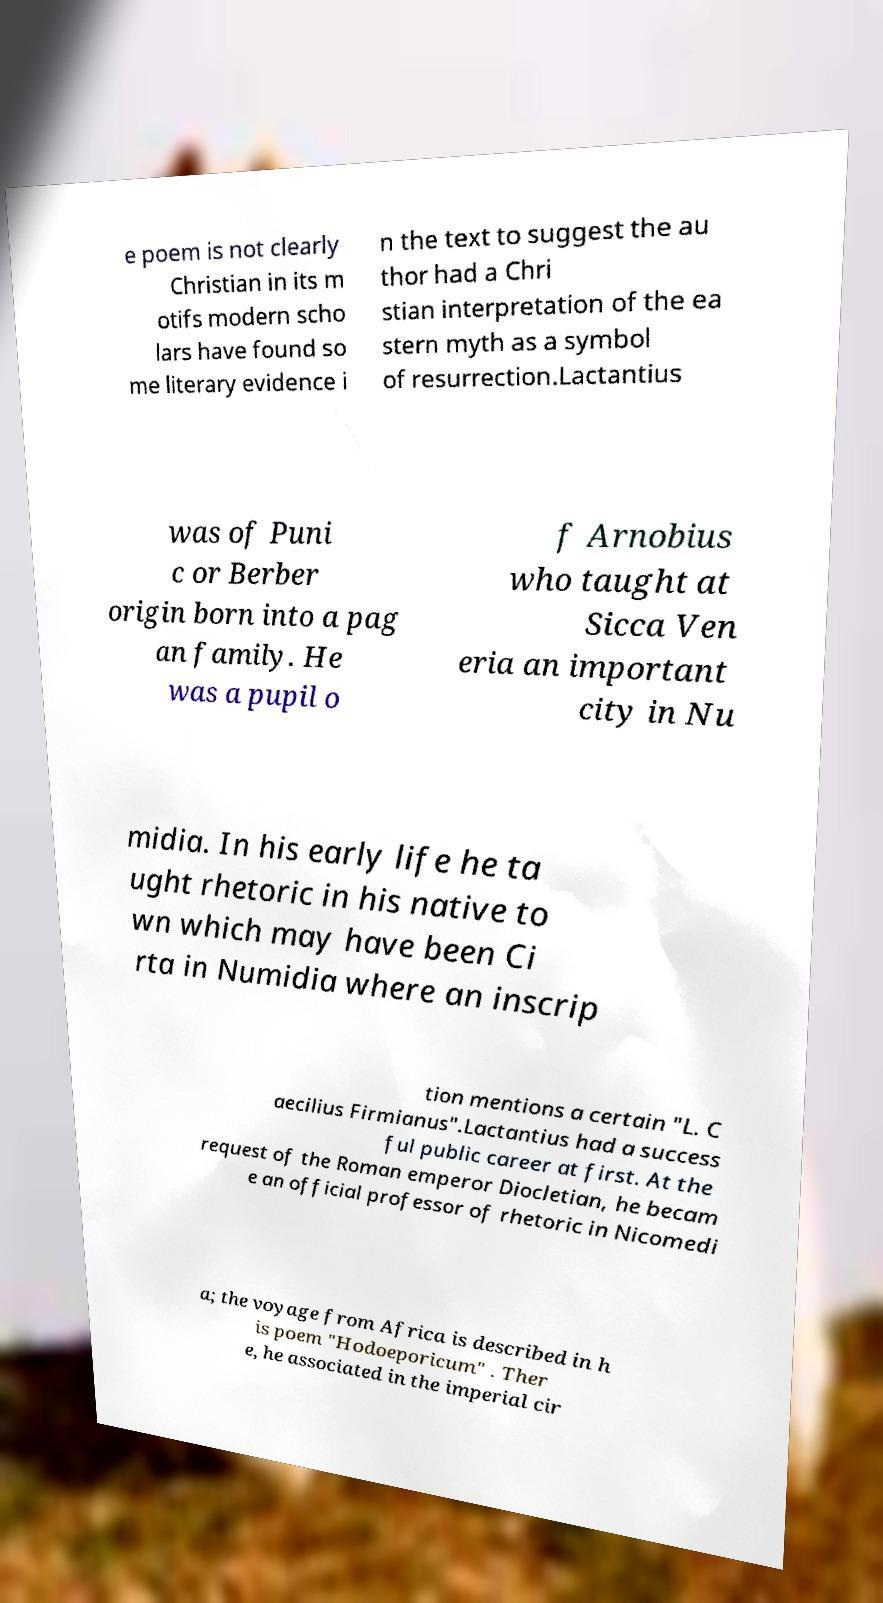Could you extract and type out the text from this image? e poem is not clearly Christian in its m otifs modern scho lars have found so me literary evidence i n the text to suggest the au thor had a Chri stian interpretation of the ea stern myth as a symbol of resurrection.Lactantius was of Puni c or Berber origin born into a pag an family. He was a pupil o f Arnobius who taught at Sicca Ven eria an important city in Nu midia. In his early life he ta ught rhetoric in his native to wn which may have been Ci rta in Numidia where an inscrip tion mentions a certain "L. C aecilius Firmianus".Lactantius had a success ful public career at first. At the request of the Roman emperor Diocletian, he becam e an official professor of rhetoric in Nicomedi a; the voyage from Africa is described in h is poem "Hodoeporicum" . Ther e, he associated in the imperial cir 